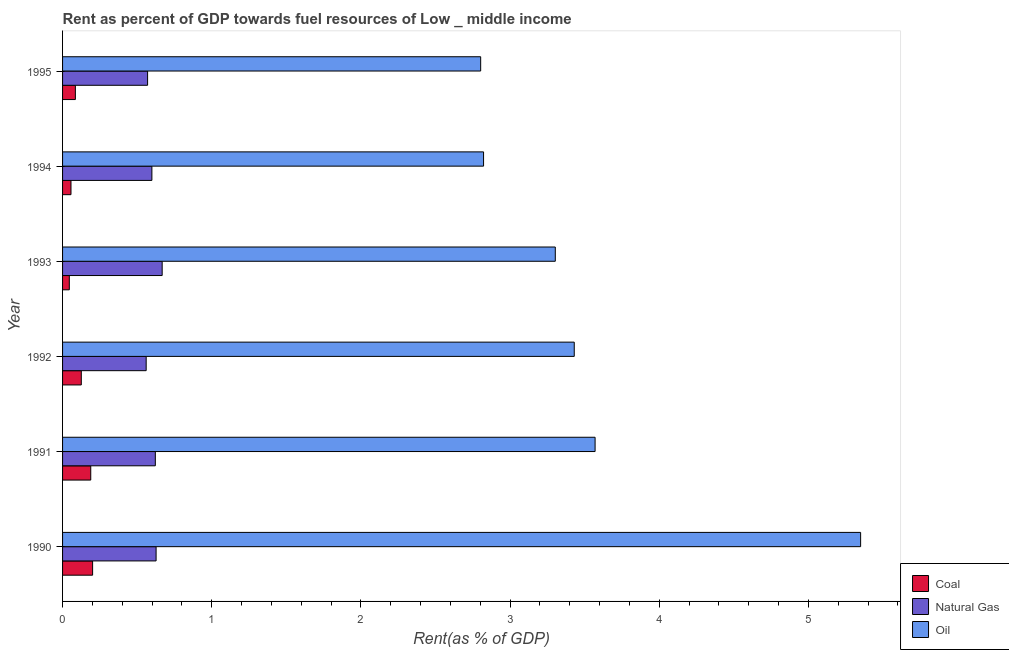How many different coloured bars are there?
Give a very brief answer. 3. How many groups of bars are there?
Provide a short and direct response. 6. What is the label of the 6th group of bars from the top?
Provide a short and direct response. 1990. What is the rent towards oil in 1994?
Your response must be concise. 2.82. Across all years, what is the maximum rent towards natural gas?
Provide a short and direct response. 0.67. Across all years, what is the minimum rent towards natural gas?
Give a very brief answer. 0.56. What is the total rent towards oil in the graph?
Provide a short and direct response. 21.28. What is the difference between the rent towards oil in 1990 and that in 1991?
Give a very brief answer. 1.78. What is the difference between the rent towards oil in 1995 and the rent towards coal in 1991?
Give a very brief answer. 2.61. What is the average rent towards oil per year?
Your response must be concise. 3.55. In the year 1990, what is the difference between the rent towards coal and rent towards oil?
Make the answer very short. -5.15. Is the rent towards coal in 1993 less than that in 1995?
Your answer should be compact. Yes. What is the difference between the highest and the second highest rent towards coal?
Offer a very short reply. 0.01. What is the difference between the highest and the lowest rent towards natural gas?
Your response must be concise. 0.11. Is the sum of the rent towards coal in 1990 and 1991 greater than the maximum rent towards oil across all years?
Make the answer very short. No. What does the 2nd bar from the top in 1992 represents?
Make the answer very short. Natural Gas. What does the 2nd bar from the bottom in 1993 represents?
Your answer should be compact. Natural Gas. Are all the bars in the graph horizontal?
Your answer should be very brief. Yes. How many years are there in the graph?
Offer a terse response. 6. Are the values on the major ticks of X-axis written in scientific E-notation?
Keep it short and to the point. No. Does the graph contain grids?
Ensure brevity in your answer.  No. Where does the legend appear in the graph?
Your answer should be very brief. Bottom right. How many legend labels are there?
Provide a succinct answer. 3. What is the title of the graph?
Provide a short and direct response. Rent as percent of GDP towards fuel resources of Low _ middle income. What is the label or title of the X-axis?
Provide a succinct answer. Rent(as % of GDP). What is the label or title of the Y-axis?
Offer a terse response. Year. What is the Rent(as % of GDP) of Coal in 1990?
Your answer should be very brief. 0.2. What is the Rent(as % of GDP) in Natural Gas in 1990?
Your answer should be very brief. 0.63. What is the Rent(as % of GDP) of Oil in 1990?
Offer a very short reply. 5.35. What is the Rent(as % of GDP) in Coal in 1991?
Provide a succinct answer. 0.19. What is the Rent(as % of GDP) in Natural Gas in 1991?
Ensure brevity in your answer.  0.62. What is the Rent(as % of GDP) of Oil in 1991?
Offer a terse response. 3.57. What is the Rent(as % of GDP) in Coal in 1992?
Offer a terse response. 0.13. What is the Rent(as % of GDP) in Natural Gas in 1992?
Ensure brevity in your answer.  0.56. What is the Rent(as % of GDP) in Oil in 1992?
Offer a very short reply. 3.43. What is the Rent(as % of GDP) of Coal in 1993?
Provide a short and direct response. 0.05. What is the Rent(as % of GDP) of Natural Gas in 1993?
Your response must be concise. 0.67. What is the Rent(as % of GDP) of Oil in 1993?
Offer a terse response. 3.3. What is the Rent(as % of GDP) of Coal in 1994?
Offer a terse response. 0.06. What is the Rent(as % of GDP) in Natural Gas in 1994?
Your answer should be compact. 0.6. What is the Rent(as % of GDP) of Oil in 1994?
Make the answer very short. 2.82. What is the Rent(as % of GDP) in Coal in 1995?
Make the answer very short. 0.09. What is the Rent(as % of GDP) in Natural Gas in 1995?
Ensure brevity in your answer.  0.57. What is the Rent(as % of GDP) of Oil in 1995?
Offer a very short reply. 2.8. Across all years, what is the maximum Rent(as % of GDP) in Coal?
Your response must be concise. 0.2. Across all years, what is the maximum Rent(as % of GDP) of Natural Gas?
Provide a short and direct response. 0.67. Across all years, what is the maximum Rent(as % of GDP) in Oil?
Your response must be concise. 5.35. Across all years, what is the minimum Rent(as % of GDP) of Coal?
Give a very brief answer. 0.05. Across all years, what is the minimum Rent(as % of GDP) in Natural Gas?
Offer a terse response. 0.56. Across all years, what is the minimum Rent(as % of GDP) of Oil?
Offer a terse response. 2.8. What is the total Rent(as % of GDP) in Coal in the graph?
Offer a terse response. 0.7. What is the total Rent(as % of GDP) of Natural Gas in the graph?
Ensure brevity in your answer.  3.65. What is the total Rent(as % of GDP) in Oil in the graph?
Your answer should be very brief. 21.28. What is the difference between the Rent(as % of GDP) in Coal in 1990 and that in 1991?
Offer a terse response. 0.01. What is the difference between the Rent(as % of GDP) in Natural Gas in 1990 and that in 1991?
Keep it short and to the point. 0.01. What is the difference between the Rent(as % of GDP) in Oil in 1990 and that in 1991?
Give a very brief answer. 1.78. What is the difference between the Rent(as % of GDP) in Coal in 1990 and that in 1992?
Offer a very short reply. 0.08. What is the difference between the Rent(as % of GDP) of Natural Gas in 1990 and that in 1992?
Make the answer very short. 0.07. What is the difference between the Rent(as % of GDP) of Oil in 1990 and that in 1992?
Make the answer very short. 1.92. What is the difference between the Rent(as % of GDP) of Coal in 1990 and that in 1993?
Give a very brief answer. 0.16. What is the difference between the Rent(as % of GDP) of Natural Gas in 1990 and that in 1993?
Your answer should be very brief. -0.04. What is the difference between the Rent(as % of GDP) in Oil in 1990 and that in 1993?
Provide a short and direct response. 2.05. What is the difference between the Rent(as % of GDP) of Coal in 1990 and that in 1994?
Keep it short and to the point. 0.14. What is the difference between the Rent(as % of GDP) in Natural Gas in 1990 and that in 1994?
Your response must be concise. 0.03. What is the difference between the Rent(as % of GDP) of Oil in 1990 and that in 1994?
Keep it short and to the point. 2.53. What is the difference between the Rent(as % of GDP) in Coal in 1990 and that in 1995?
Your answer should be compact. 0.12. What is the difference between the Rent(as % of GDP) of Natural Gas in 1990 and that in 1995?
Offer a very short reply. 0.06. What is the difference between the Rent(as % of GDP) in Oil in 1990 and that in 1995?
Provide a succinct answer. 2.55. What is the difference between the Rent(as % of GDP) of Coal in 1991 and that in 1992?
Give a very brief answer. 0.06. What is the difference between the Rent(as % of GDP) of Natural Gas in 1991 and that in 1992?
Your response must be concise. 0.06. What is the difference between the Rent(as % of GDP) of Oil in 1991 and that in 1992?
Offer a very short reply. 0.14. What is the difference between the Rent(as % of GDP) of Coal in 1991 and that in 1993?
Keep it short and to the point. 0.14. What is the difference between the Rent(as % of GDP) in Natural Gas in 1991 and that in 1993?
Your answer should be very brief. -0.05. What is the difference between the Rent(as % of GDP) of Oil in 1991 and that in 1993?
Provide a succinct answer. 0.27. What is the difference between the Rent(as % of GDP) in Coal in 1991 and that in 1994?
Give a very brief answer. 0.13. What is the difference between the Rent(as % of GDP) of Natural Gas in 1991 and that in 1994?
Provide a short and direct response. 0.02. What is the difference between the Rent(as % of GDP) in Oil in 1991 and that in 1994?
Offer a terse response. 0.75. What is the difference between the Rent(as % of GDP) of Coal in 1991 and that in 1995?
Give a very brief answer. 0.1. What is the difference between the Rent(as % of GDP) of Natural Gas in 1991 and that in 1995?
Make the answer very short. 0.05. What is the difference between the Rent(as % of GDP) in Oil in 1991 and that in 1995?
Provide a succinct answer. 0.77. What is the difference between the Rent(as % of GDP) of Coal in 1992 and that in 1993?
Provide a succinct answer. 0.08. What is the difference between the Rent(as % of GDP) in Natural Gas in 1992 and that in 1993?
Provide a short and direct response. -0.11. What is the difference between the Rent(as % of GDP) of Oil in 1992 and that in 1993?
Make the answer very short. 0.13. What is the difference between the Rent(as % of GDP) of Coal in 1992 and that in 1994?
Your answer should be compact. 0.07. What is the difference between the Rent(as % of GDP) in Natural Gas in 1992 and that in 1994?
Your answer should be compact. -0.04. What is the difference between the Rent(as % of GDP) in Oil in 1992 and that in 1994?
Your response must be concise. 0.61. What is the difference between the Rent(as % of GDP) of Coal in 1992 and that in 1995?
Offer a terse response. 0.04. What is the difference between the Rent(as % of GDP) of Natural Gas in 1992 and that in 1995?
Your response must be concise. -0.01. What is the difference between the Rent(as % of GDP) of Oil in 1992 and that in 1995?
Give a very brief answer. 0.63. What is the difference between the Rent(as % of GDP) of Coal in 1993 and that in 1994?
Ensure brevity in your answer.  -0.01. What is the difference between the Rent(as % of GDP) in Natural Gas in 1993 and that in 1994?
Give a very brief answer. 0.07. What is the difference between the Rent(as % of GDP) in Oil in 1993 and that in 1994?
Your answer should be compact. 0.48. What is the difference between the Rent(as % of GDP) in Coal in 1993 and that in 1995?
Give a very brief answer. -0.04. What is the difference between the Rent(as % of GDP) of Natural Gas in 1993 and that in 1995?
Your answer should be compact. 0.1. What is the difference between the Rent(as % of GDP) of Oil in 1993 and that in 1995?
Keep it short and to the point. 0.5. What is the difference between the Rent(as % of GDP) of Coal in 1994 and that in 1995?
Offer a terse response. -0.03. What is the difference between the Rent(as % of GDP) of Natural Gas in 1994 and that in 1995?
Give a very brief answer. 0.03. What is the difference between the Rent(as % of GDP) in Oil in 1994 and that in 1995?
Your answer should be very brief. 0.02. What is the difference between the Rent(as % of GDP) of Coal in 1990 and the Rent(as % of GDP) of Natural Gas in 1991?
Provide a succinct answer. -0.42. What is the difference between the Rent(as % of GDP) of Coal in 1990 and the Rent(as % of GDP) of Oil in 1991?
Your answer should be compact. -3.37. What is the difference between the Rent(as % of GDP) in Natural Gas in 1990 and the Rent(as % of GDP) in Oil in 1991?
Give a very brief answer. -2.94. What is the difference between the Rent(as % of GDP) of Coal in 1990 and the Rent(as % of GDP) of Natural Gas in 1992?
Make the answer very short. -0.36. What is the difference between the Rent(as % of GDP) of Coal in 1990 and the Rent(as % of GDP) of Oil in 1992?
Ensure brevity in your answer.  -3.23. What is the difference between the Rent(as % of GDP) in Natural Gas in 1990 and the Rent(as % of GDP) in Oil in 1992?
Give a very brief answer. -2.8. What is the difference between the Rent(as % of GDP) of Coal in 1990 and the Rent(as % of GDP) of Natural Gas in 1993?
Your answer should be compact. -0.47. What is the difference between the Rent(as % of GDP) of Coal in 1990 and the Rent(as % of GDP) of Oil in 1993?
Give a very brief answer. -3.1. What is the difference between the Rent(as % of GDP) in Natural Gas in 1990 and the Rent(as % of GDP) in Oil in 1993?
Give a very brief answer. -2.68. What is the difference between the Rent(as % of GDP) of Coal in 1990 and the Rent(as % of GDP) of Natural Gas in 1994?
Provide a short and direct response. -0.4. What is the difference between the Rent(as % of GDP) in Coal in 1990 and the Rent(as % of GDP) in Oil in 1994?
Ensure brevity in your answer.  -2.62. What is the difference between the Rent(as % of GDP) in Natural Gas in 1990 and the Rent(as % of GDP) in Oil in 1994?
Ensure brevity in your answer.  -2.2. What is the difference between the Rent(as % of GDP) in Coal in 1990 and the Rent(as % of GDP) in Natural Gas in 1995?
Provide a short and direct response. -0.37. What is the difference between the Rent(as % of GDP) in Coal in 1990 and the Rent(as % of GDP) in Oil in 1995?
Provide a short and direct response. -2.6. What is the difference between the Rent(as % of GDP) of Natural Gas in 1990 and the Rent(as % of GDP) of Oil in 1995?
Your answer should be very brief. -2.18. What is the difference between the Rent(as % of GDP) in Coal in 1991 and the Rent(as % of GDP) in Natural Gas in 1992?
Ensure brevity in your answer.  -0.37. What is the difference between the Rent(as % of GDP) in Coal in 1991 and the Rent(as % of GDP) in Oil in 1992?
Offer a terse response. -3.24. What is the difference between the Rent(as % of GDP) of Natural Gas in 1991 and the Rent(as % of GDP) of Oil in 1992?
Give a very brief answer. -2.81. What is the difference between the Rent(as % of GDP) of Coal in 1991 and the Rent(as % of GDP) of Natural Gas in 1993?
Offer a terse response. -0.48. What is the difference between the Rent(as % of GDP) in Coal in 1991 and the Rent(as % of GDP) in Oil in 1993?
Your answer should be very brief. -3.11. What is the difference between the Rent(as % of GDP) in Natural Gas in 1991 and the Rent(as % of GDP) in Oil in 1993?
Offer a terse response. -2.68. What is the difference between the Rent(as % of GDP) of Coal in 1991 and the Rent(as % of GDP) of Natural Gas in 1994?
Give a very brief answer. -0.41. What is the difference between the Rent(as % of GDP) in Coal in 1991 and the Rent(as % of GDP) in Oil in 1994?
Provide a short and direct response. -2.63. What is the difference between the Rent(as % of GDP) of Natural Gas in 1991 and the Rent(as % of GDP) of Oil in 1994?
Keep it short and to the point. -2.2. What is the difference between the Rent(as % of GDP) in Coal in 1991 and the Rent(as % of GDP) in Natural Gas in 1995?
Provide a short and direct response. -0.38. What is the difference between the Rent(as % of GDP) of Coal in 1991 and the Rent(as % of GDP) of Oil in 1995?
Provide a short and direct response. -2.61. What is the difference between the Rent(as % of GDP) in Natural Gas in 1991 and the Rent(as % of GDP) in Oil in 1995?
Your answer should be very brief. -2.18. What is the difference between the Rent(as % of GDP) in Coal in 1992 and the Rent(as % of GDP) in Natural Gas in 1993?
Give a very brief answer. -0.54. What is the difference between the Rent(as % of GDP) in Coal in 1992 and the Rent(as % of GDP) in Oil in 1993?
Provide a succinct answer. -3.18. What is the difference between the Rent(as % of GDP) of Natural Gas in 1992 and the Rent(as % of GDP) of Oil in 1993?
Your response must be concise. -2.74. What is the difference between the Rent(as % of GDP) of Coal in 1992 and the Rent(as % of GDP) of Natural Gas in 1994?
Your response must be concise. -0.47. What is the difference between the Rent(as % of GDP) of Coal in 1992 and the Rent(as % of GDP) of Oil in 1994?
Keep it short and to the point. -2.7. What is the difference between the Rent(as % of GDP) in Natural Gas in 1992 and the Rent(as % of GDP) in Oil in 1994?
Make the answer very short. -2.26. What is the difference between the Rent(as % of GDP) of Coal in 1992 and the Rent(as % of GDP) of Natural Gas in 1995?
Offer a terse response. -0.44. What is the difference between the Rent(as % of GDP) of Coal in 1992 and the Rent(as % of GDP) of Oil in 1995?
Offer a terse response. -2.68. What is the difference between the Rent(as % of GDP) in Natural Gas in 1992 and the Rent(as % of GDP) in Oil in 1995?
Ensure brevity in your answer.  -2.24. What is the difference between the Rent(as % of GDP) in Coal in 1993 and the Rent(as % of GDP) in Natural Gas in 1994?
Make the answer very short. -0.55. What is the difference between the Rent(as % of GDP) of Coal in 1993 and the Rent(as % of GDP) of Oil in 1994?
Offer a terse response. -2.78. What is the difference between the Rent(as % of GDP) in Natural Gas in 1993 and the Rent(as % of GDP) in Oil in 1994?
Make the answer very short. -2.15. What is the difference between the Rent(as % of GDP) in Coal in 1993 and the Rent(as % of GDP) in Natural Gas in 1995?
Offer a terse response. -0.52. What is the difference between the Rent(as % of GDP) in Coal in 1993 and the Rent(as % of GDP) in Oil in 1995?
Your answer should be compact. -2.76. What is the difference between the Rent(as % of GDP) in Natural Gas in 1993 and the Rent(as % of GDP) in Oil in 1995?
Keep it short and to the point. -2.14. What is the difference between the Rent(as % of GDP) in Coal in 1994 and the Rent(as % of GDP) in Natural Gas in 1995?
Keep it short and to the point. -0.51. What is the difference between the Rent(as % of GDP) of Coal in 1994 and the Rent(as % of GDP) of Oil in 1995?
Keep it short and to the point. -2.75. What is the difference between the Rent(as % of GDP) of Natural Gas in 1994 and the Rent(as % of GDP) of Oil in 1995?
Your answer should be compact. -2.2. What is the average Rent(as % of GDP) of Coal per year?
Provide a succinct answer. 0.12. What is the average Rent(as % of GDP) in Natural Gas per year?
Make the answer very short. 0.61. What is the average Rent(as % of GDP) of Oil per year?
Offer a very short reply. 3.55. In the year 1990, what is the difference between the Rent(as % of GDP) of Coal and Rent(as % of GDP) of Natural Gas?
Ensure brevity in your answer.  -0.43. In the year 1990, what is the difference between the Rent(as % of GDP) in Coal and Rent(as % of GDP) in Oil?
Give a very brief answer. -5.15. In the year 1990, what is the difference between the Rent(as % of GDP) in Natural Gas and Rent(as % of GDP) in Oil?
Offer a very short reply. -4.72. In the year 1991, what is the difference between the Rent(as % of GDP) of Coal and Rent(as % of GDP) of Natural Gas?
Your response must be concise. -0.43. In the year 1991, what is the difference between the Rent(as % of GDP) of Coal and Rent(as % of GDP) of Oil?
Provide a succinct answer. -3.38. In the year 1991, what is the difference between the Rent(as % of GDP) in Natural Gas and Rent(as % of GDP) in Oil?
Offer a very short reply. -2.95. In the year 1992, what is the difference between the Rent(as % of GDP) in Coal and Rent(as % of GDP) in Natural Gas?
Provide a succinct answer. -0.43. In the year 1992, what is the difference between the Rent(as % of GDP) in Coal and Rent(as % of GDP) in Oil?
Provide a short and direct response. -3.3. In the year 1992, what is the difference between the Rent(as % of GDP) in Natural Gas and Rent(as % of GDP) in Oil?
Offer a very short reply. -2.87. In the year 1993, what is the difference between the Rent(as % of GDP) in Coal and Rent(as % of GDP) in Natural Gas?
Offer a terse response. -0.62. In the year 1993, what is the difference between the Rent(as % of GDP) in Coal and Rent(as % of GDP) in Oil?
Provide a short and direct response. -3.26. In the year 1993, what is the difference between the Rent(as % of GDP) of Natural Gas and Rent(as % of GDP) of Oil?
Ensure brevity in your answer.  -2.64. In the year 1994, what is the difference between the Rent(as % of GDP) in Coal and Rent(as % of GDP) in Natural Gas?
Ensure brevity in your answer.  -0.54. In the year 1994, what is the difference between the Rent(as % of GDP) in Coal and Rent(as % of GDP) in Oil?
Your answer should be compact. -2.77. In the year 1994, what is the difference between the Rent(as % of GDP) in Natural Gas and Rent(as % of GDP) in Oil?
Your response must be concise. -2.22. In the year 1995, what is the difference between the Rent(as % of GDP) of Coal and Rent(as % of GDP) of Natural Gas?
Offer a terse response. -0.48. In the year 1995, what is the difference between the Rent(as % of GDP) of Coal and Rent(as % of GDP) of Oil?
Make the answer very short. -2.72. In the year 1995, what is the difference between the Rent(as % of GDP) of Natural Gas and Rent(as % of GDP) of Oil?
Your response must be concise. -2.23. What is the ratio of the Rent(as % of GDP) of Coal in 1990 to that in 1991?
Provide a short and direct response. 1.07. What is the ratio of the Rent(as % of GDP) of Natural Gas in 1990 to that in 1991?
Your answer should be very brief. 1.01. What is the ratio of the Rent(as % of GDP) of Oil in 1990 to that in 1991?
Ensure brevity in your answer.  1.5. What is the ratio of the Rent(as % of GDP) of Coal in 1990 to that in 1992?
Keep it short and to the point. 1.6. What is the ratio of the Rent(as % of GDP) in Natural Gas in 1990 to that in 1992?
Offer a very short reply. 1.12. What is the ratio of the Rent(as % of GDP) of Oil in 1990 to that in 1992?
Offer a terse response. 1.56. What is the ratio of the Rent(as % of GDP) of Coal in 1990 to that in 1993?
Offer a very short reply. 4.45. What is the ratio of the Rent(as % of GDP) in Natural Gas in 1990 to that in 1993?
Your answer should be very brief. 0.94. What is the ratio of the Rent(as % of GDP) of Oil in 1990 to that in 1993?
Make the answer very short. 1.62. What is the ratio of the Rent(as % of GDP) in Coal in 1990 to that in 1994?
Give a very brief answer. 3.57. What is the ratio of the Rent(as % of GDP) in Natural Gas in 1990 to that in 1994?
Offer a terse response. 1.05. What is the ratio of the Rent(as % of GDP) in Oil in 1990 to that in 1994?
Provide a succinct answer. 1.9. What is the ratio of the Rent(as % of GDP) in Coal in 1990 to that in 1995?
Keep it short and to the point. 2.35. What is the ratio of the Rent(as % of GDP) in Natural Gas in 1990 to that in 1995?
Keep it short and to the point. 1.1. What is the ratio of the Rent(as % of GDP) of Oil in 1990 to that in 1995?
Keep it short and to the point. 1.91. What is the ratio of the Rent(as % of GDP) of Coal in 1991 to that in 1992?
Your answer should be compact. 1.5. What is the ratio of the Rent(as % of GDP) in Natural Gas in 1991 to that in 1992?
Your answer should be compact. 1.11. What is the ratio of the Rent(as % of GDP) in Oil in 1991 to that in 1992?
Offer a terse response. 1.04. What is the ratio of the Rent(as % of GDP) in Coal in 1991 to that in 1993?
Your response must be concise. 4.17. What is the ratio of the Rent(as % of GDP) in Natural Gas in 1991 to that in 1993?
Ensure brevity in your answer.  0.93. What is the ratio of the Rent(as % of GDP) of Oil in 1991 to that in 1993?
Give a very brief answer. 1.08. What is the ratio of the Rent(as % of GDP) of Coal in 1991 to that in 1994?
Provide a succinct answer. 3.34. What is the ratio of the Rent(as % of GDP) in Oil in 1991 to that in 1994?
Offer a very short reply. 1.26. What is the ratio of the Rent(as % of GDP) in Coal in 1991 to that in 1995?
Provide a short and direct response. 2.2. What is the ratio of the Rent(as % of GDP) in Natural Gas in 1991 to that in 1995?
Your answer should be very brief. 1.09. What is the ratio of the Rent(as % of GDP) in Oil in 1991 to that in 1995?
Keep it short and to the point. 1.27. What is the ratio of the Rent(as % of GDP) in Coal in 1992 to that in 1993?
Give a very brief answer. 2.77. What is the ratio of the Rent(as % of GDP) of Natural Gas in 1992 to that in 1993?
Offer a terse response. 0.84. What is the ratio of the Rent(as % of GDP) of Oil in 1992 to that in 1993?
Provide a succinct answer. 1.04. What is the ratio of the Rent(as % of GDP) of Coal in 1992 to that in 1994?
Your answer should be compact. 2.22. What is the ratio of the Rent(as % of GDP) in Natural Gas in 1992 to that in 1994?
Keep it short and to the point. 0.94. What is the ratio of the Rent(as % of GDP) in Oil in 1992 to that in 1994?
Your answer should be compact. 1.22. What is the ratio of the Rent(as % of GDP) in Coal in 1992 to that in 1995?
Offer a very short reply. 1.46. What is the ratio of the Rent(as % of GDP) in Natural Gas in 1992 to that in 1995?
Keep it short and to the point. 0.98. What is the ratio of the Rent(as % of GDP) of Oil in 1992 to that in 1995?
Your answer should be compact. 1.22. What is the ratio of the Rent(as % of GDP) of Coal in 1993 to that in 1994?
Give a very brief answer. 0.8. What is the ratio of the Rent(as % of GDP) in Natural Gas in 1993 to that in 1994?
Your answer should be compact. 1.11. What is the ratio of the Rent(as % of GDP) in Oil in 1993 to that in 1994?
Offer a terse response. 1.17. What is the ratio of the Rent(as % of GDP) in Coal in 1993 to that in 1995?
Give a very brief answer. 0.53. What is the ratio of the Rent(as % of GDP) in Natural Gas in 1993 to that in 1995?
Keep it short and to the point. 1.17. What is the ratio of the Rent(as % of GDP) in Oil in 1993 to that in 1995?
Provide a succinct answer. 1.18. What is the ratio of the Rent(as % of GDP) in Coal in 1994 to that in 1995?
Ensure brevity in your answer.  0.66. What is the ratio of the Rent(as % of GDP) in Natural Gas in 1994 to that in 1995?
Your response must be concise. 1.05. What is the ratio of the Rent(as % of GDP) in Oil in 1994 to that in 1995?
Make the answer very short. 1.01. What is the difference between the highest and the second highest Rent(as % of GDP) of Coal?
Offer a very short reply. 0.01. What is the difference between the highest and the second highest Rent(as % of GDP) in Natural Gas?
Your answer should be compact. 0.04. What is the difference between the highest and the second highest Rent(as % of GDP) of Oil?
Your answer should be compact. 1.78. What is the difference between the highest and the lowest Rent(as % of GDP) in Coal?
Your answer should be compact. 0.16. What is the difference between the highest and the lowest Rent(as % of GDP) of Natural Gas?
Offer a terse response. 0.11. What is the difference between the highest and the lowest Rent(as % of GDP) of Oil?
Ensure brevity in your answer.  2.55. 